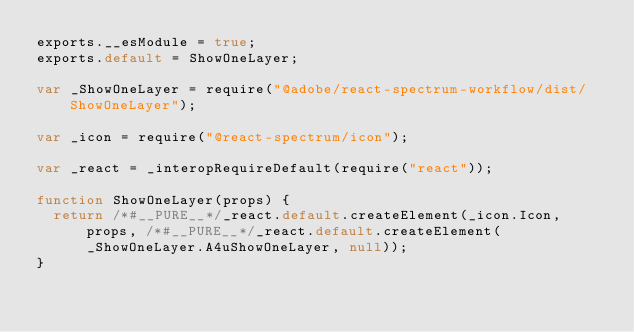Convert code to text. <code><loc_0><loc_0><loc_500><loc_500><_JavaScript_>exports.__esModule = true;
exports.default = ShowOneLayer;

var _ShowOneLayer = require("@adobe/react-spectrum-workflow/dist/ShowOneLayer");

var _icon = require("@react-spectrum/icon");

var _react = _interopRequireDefault(require("react"));

function ShowOneLayer(props) {
  return /*#__PURE__*/_react.default.createElement(_icon.Icon, props, /*#__PURE__*/_react.default.createElement(_ShowOneLayer.A4uShowOneLayer, null));
}</code> 